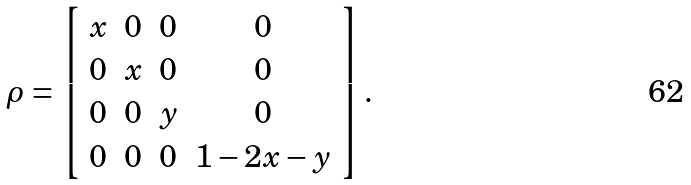Convert formula to latex. <formula><loc_0><loc_0><loc_500><loc_500>\rho = \left [ \begin{array} { c c c c } x & 0 & 0 & 0 \\ 0 & x & 0 & 0 \\ 0 & 0 & y & 0 \\ 0 & 0 & 0 & 1 - 2 x - y \\ \end{array} \right ] .</formula> 